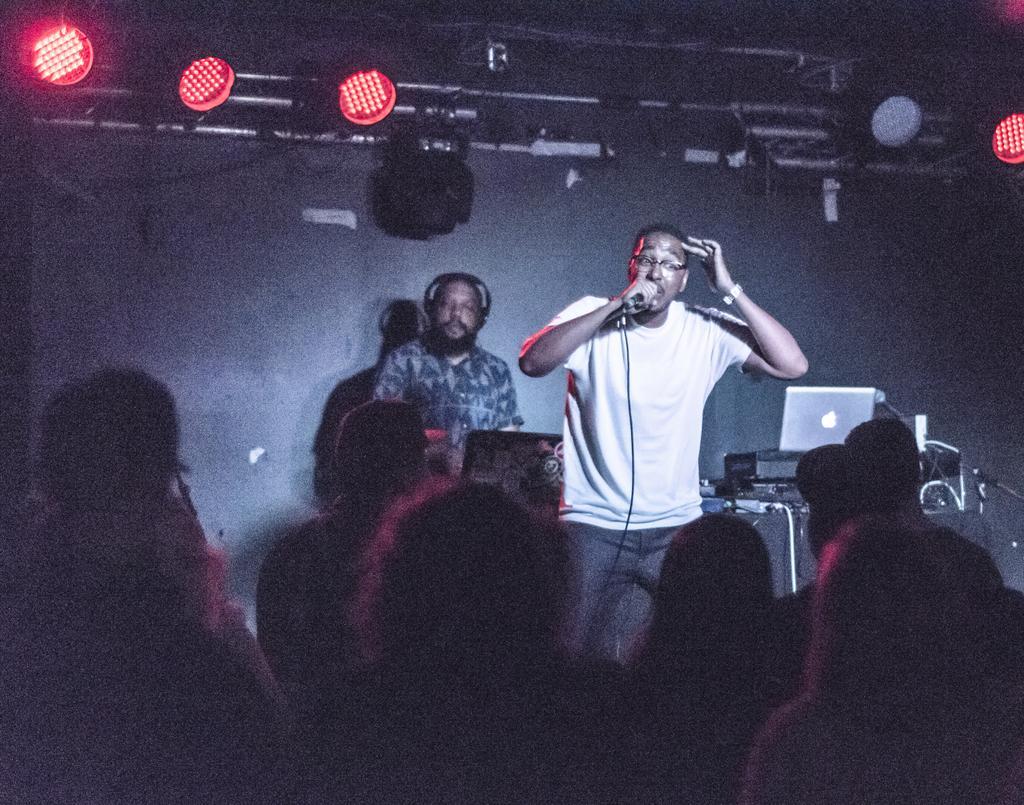Can you describe this image briefly? In a room there are lot of crowd and two man standing on stage. one holding microphone and other wearing headset. Behind them there are laptops and at top lights projecting on crowd. 